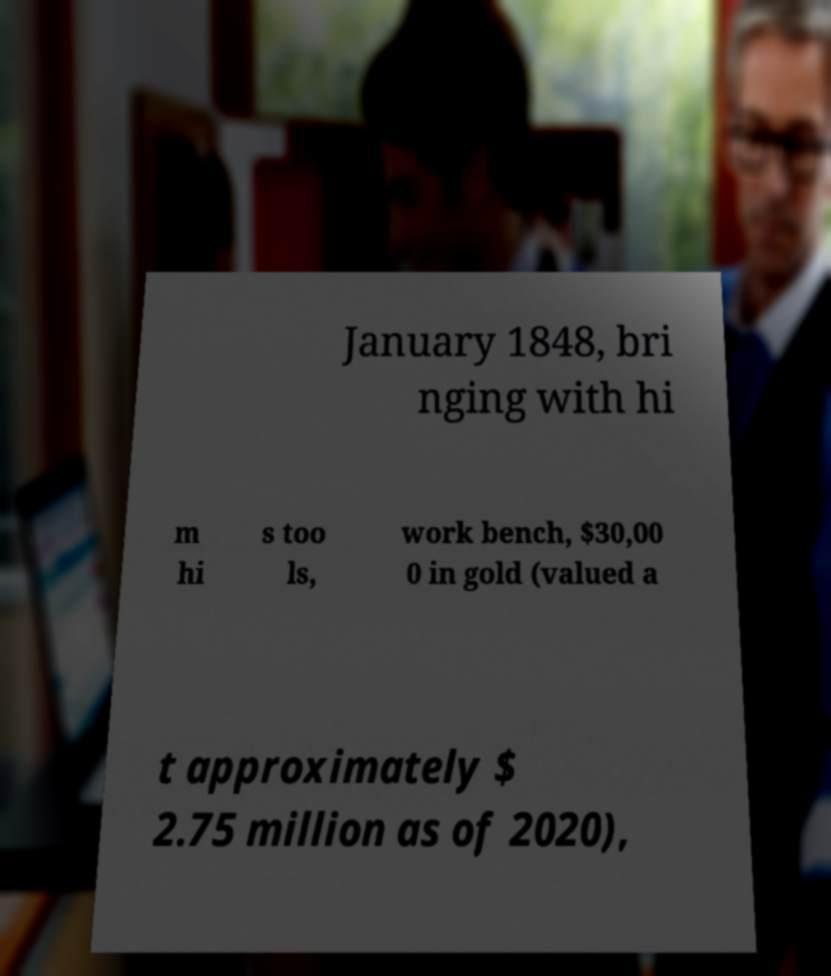Please identify and transcribe the text found in this image. January 1848, bri nging with hi m hi s too ls, work bench, $30,00 0 in gold (valued a t approximately $ 2.75 million as of 2020), 